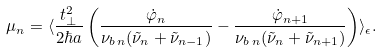<formula> <loc_0><loc_0><loc_500><loc_500>\mu _ { n } = \langle \frac { t _ { \perp } ^ { 2 } } { 2 \hbar { a } } \left ( \frac { \dot { \varphi } _ { n } } { \nu _ { b \, n } ( \tilde { \nu } _ { n } + \tilde { \nu } _ { n - 1 } ) } - \frac { \dot { \varphi } _ { n + 1 } } { \nu _ { b \, n } ( \tilde { \nu } _ { n } + \tilde { \nu } _ { n + 1 } ) } \right ) \rangle _ { \epsilon } .</formula> 